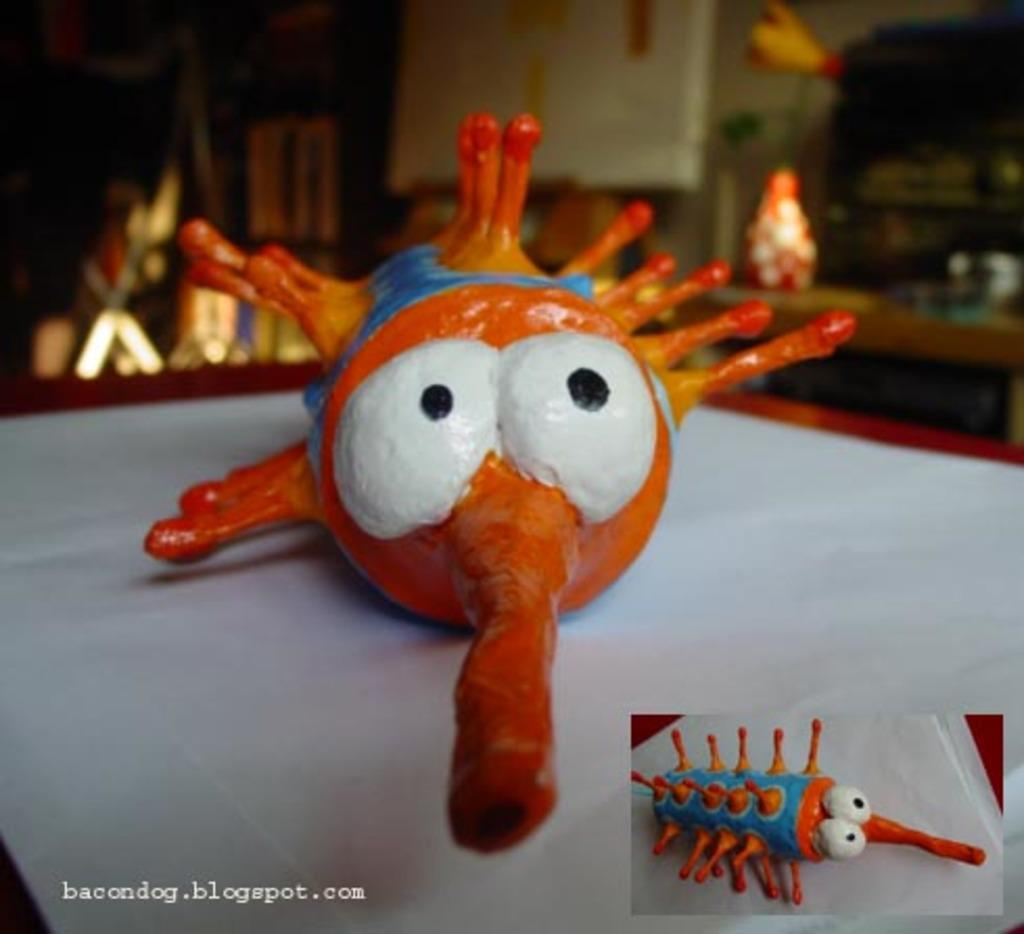What is the main subject in the center of the image? There is a toy in the center of the image. What else can be seen at the bottom side of the image? There is an image of a toy and text at the bottom side of the image. How many toes can be seen on the toy in the image? There are no visible toes on the toy in the image, as it is not a body part or a living organism. 